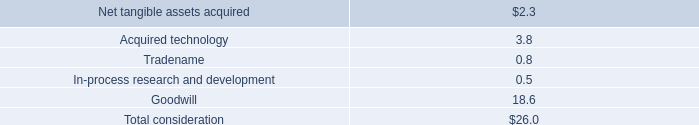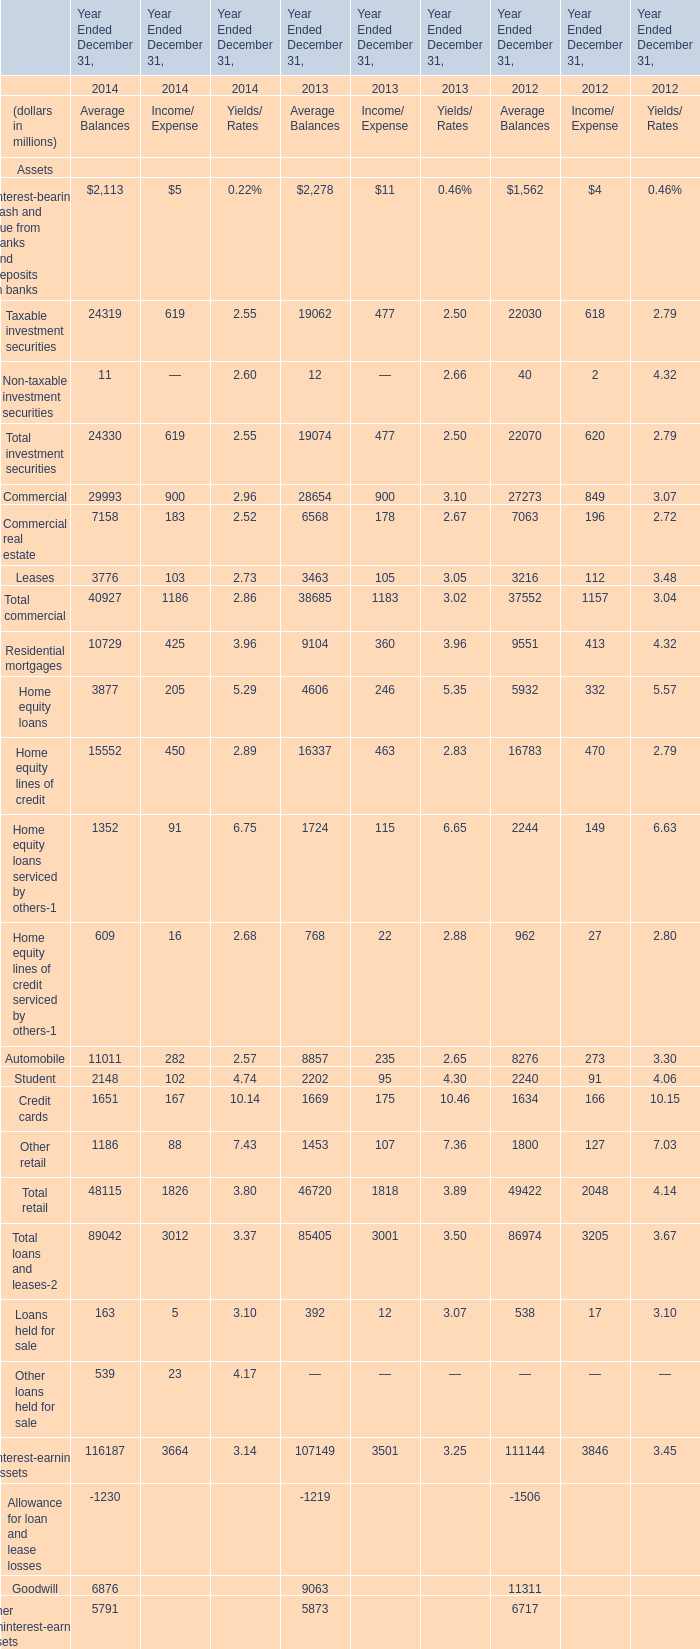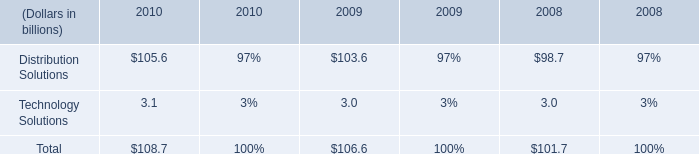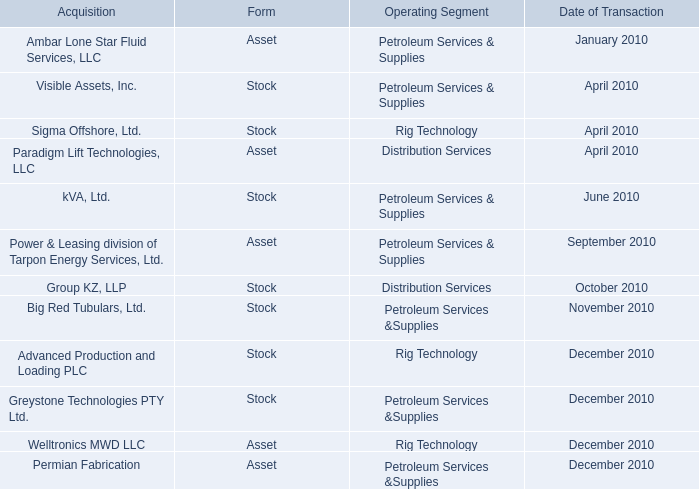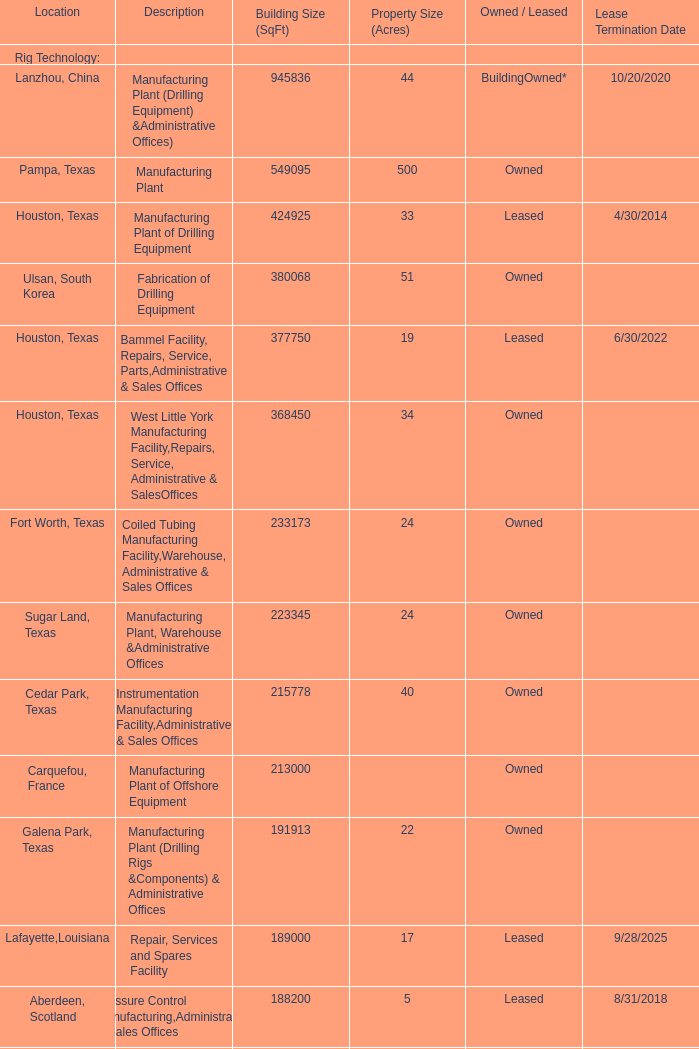What's the 80 % of Building Size (SqFt) of Manufacturing & Office Facility of Rig Technology (Orange, California)? 
Computations: (0.8 * 158268)
Answer: 126614.4. 